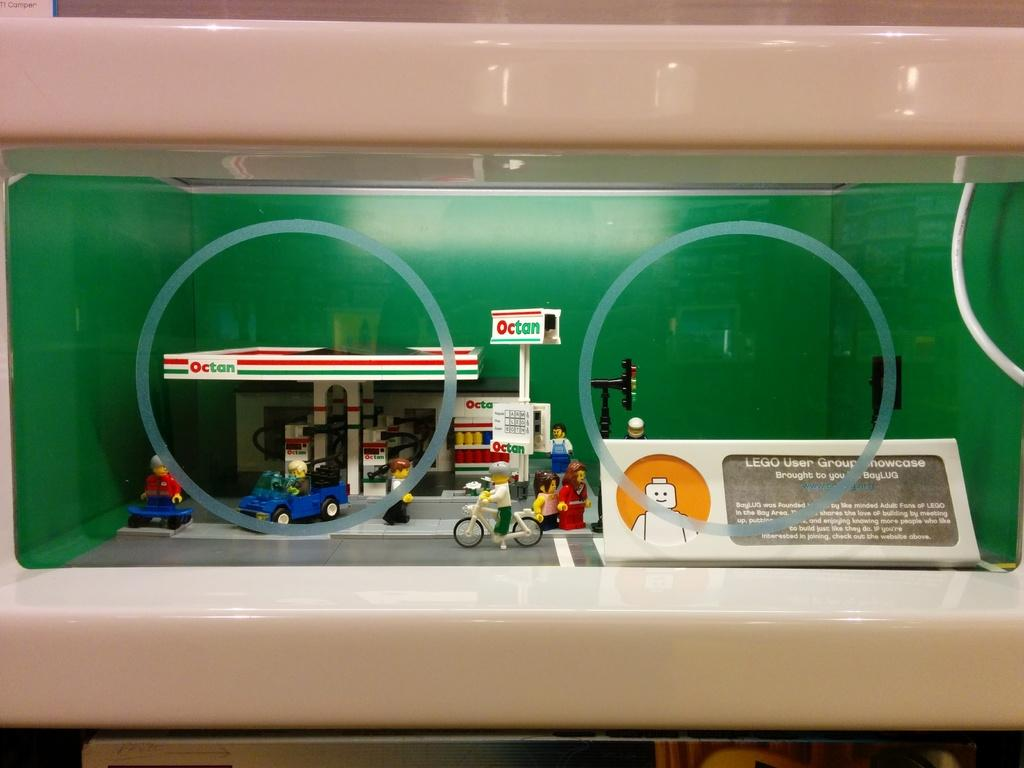What is located in the center of the image? There are toys in the glass in the center of the image. What type of cave can be seen in the background of the image? There is no cave present in the image; it only features toys in a glass. 